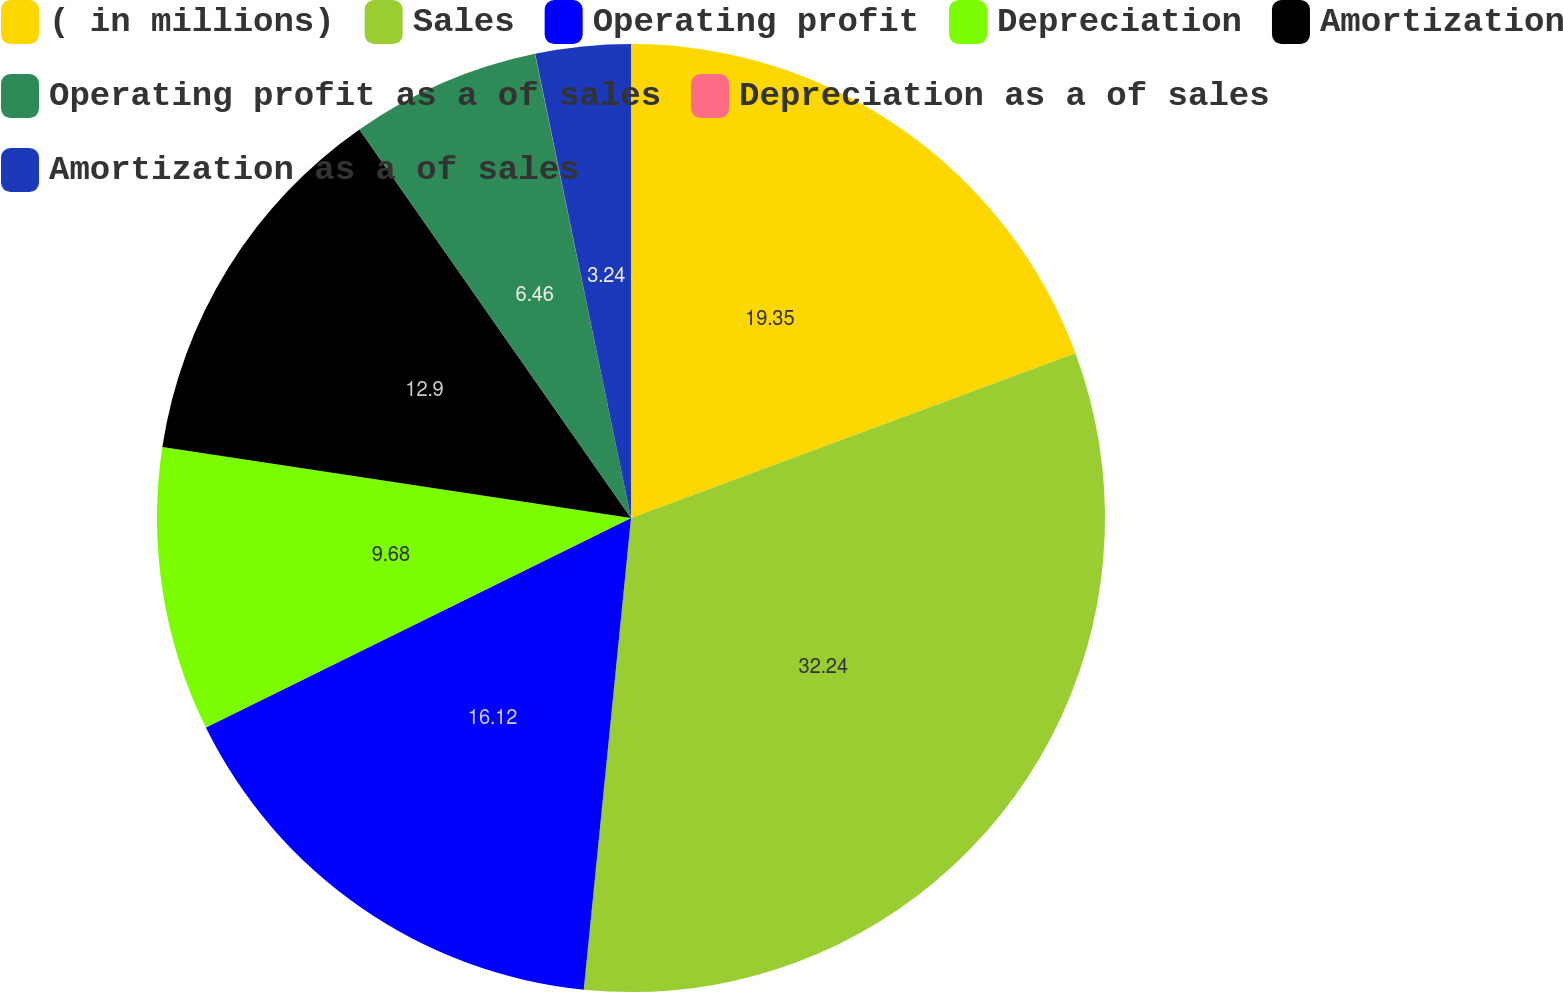<chart> <loc_0><loc_0><loc_500><loc_500><pie_chart><fcel>( in millions)<fcel>Sales<fcel>Operating profit<fcel>Depreciation<fcel>Amortization<fcel>Operating profit as a of sales<fcel>Depreciation as a of sales<fcel>Amortization as a of sales<nl><fcel>19.35%<fcel>32.24%<fcel>16.12%<fcel>9.68%<fcel>12.9%<fcel>6.46%<fcel>0.01%<fcel>3.24%<nl></chart> 